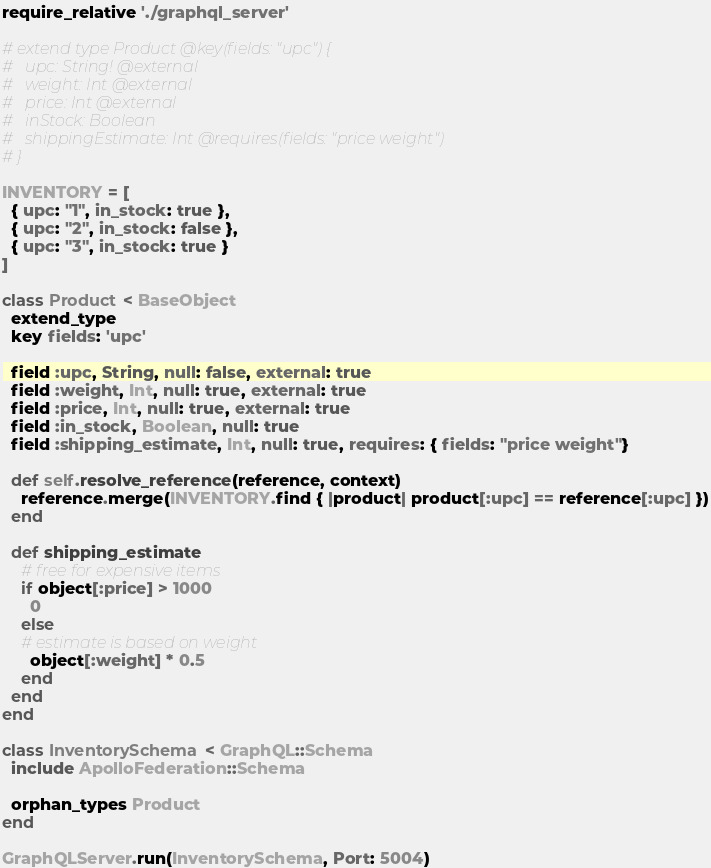<code> <loc_0><loc_0><loc_500><loc_500><_Ruby_>require_relative './graphql_server'

# extend type Product @key(fields: "upc") {
#   upc: String! @external
#   weight: Int @external
#   price: Int @external
#   inStock: Boolean
#   shippingEstimate: Int @requires(fields: "price weight")
# }

INVENTORY = [
  { upc: "1", in_stock: true },
  { upc: "2", in_stock: false },
  { upc: "3", in_stock: true }
]

class Product < BaseObject
  extend_type
  key fields: 'upc'

  field :upc, String, null: false, external: true
  field :weight, Int, null: true, external: true
  field :price, Int, null: true, external: true
  field :in_stock, Boolean, null: true
  field :shipping_estimate, Int, null: true, requires: { fields: "price weight"}

  def self.resolve_reference(reference, context)
    reference.merge(INVENTORY.find { |product| product[:upc] == reference[:upc] })
  end

  def shipping_estimate
    # free for expensive items
    if object[:price] > 1000
      0
    else
    # estimate is based on weight
      object[:weight] * 0.5
    end
  end
end

class InventorySchema < GraphQL::Schema
  include ApolloFederation::Schema

  orphan_types Product
end

GraphQLServer.run(InventorySchema, Port: 5004)
</code> 